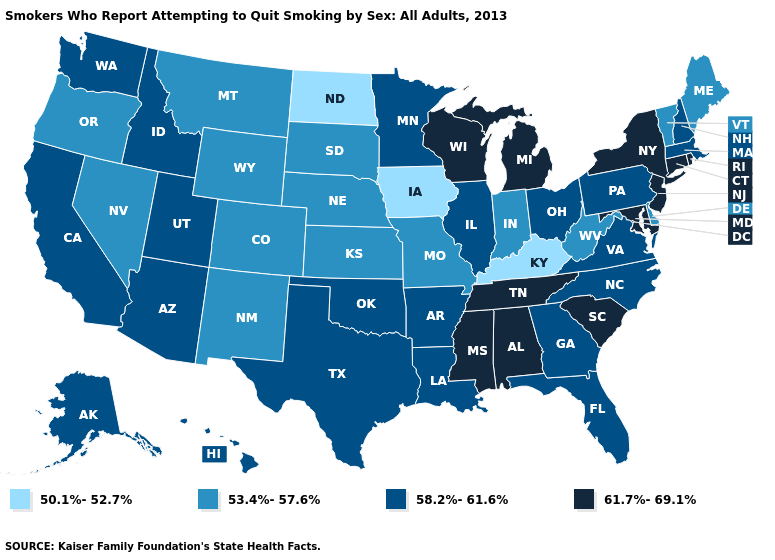What is the value of Hawaii?
Quick response, please. 58.2%-61.6%. Does Maine have the same value as Rhode Island?
Quick response, please. No. Does the map have missing data?
Answer briefly. No. Among the states that border South Dakota , which have the lowest value?
Be succinct. Iowa, North Dakota. Among the states that border New Hampshire , which have the highest value?
Write a very short answer. Massachusetts. Does the map have missing data?
Short answer required. No. What is the value of Rhode Island?
Answer briefly. 61.7%-69.1%. What is the value of Nevada?
Write a very short answer. 53.4%-57.6%. What is the value of Montana?
Answer briefly. 53.4%-57.6%. Name the states that have a value in the range 53.4%-57.6%?
Write a very short answer. Colorado, Delaware, Indiana, Kansas, Maine, Missouri, Montana, Nebraska, Nevada, New Mexico, Oregon, South Dakota, Vermont, West Virginia, Wyoming. What is the value of Florida?
Be succinct. 58.2%-61.6%. Does California have a higher value than Illinois?
Give a very brief answer. No. What is the value of Vermont?
Be succinct. 53.4%-57.6%. Does Kentucky have the lowest value in the South?
Be succinct. Yes. Name the states that have a value in the range 50.1%-52.7%?
Quick response, please. Iowa, Kentucky, North Dakota. 